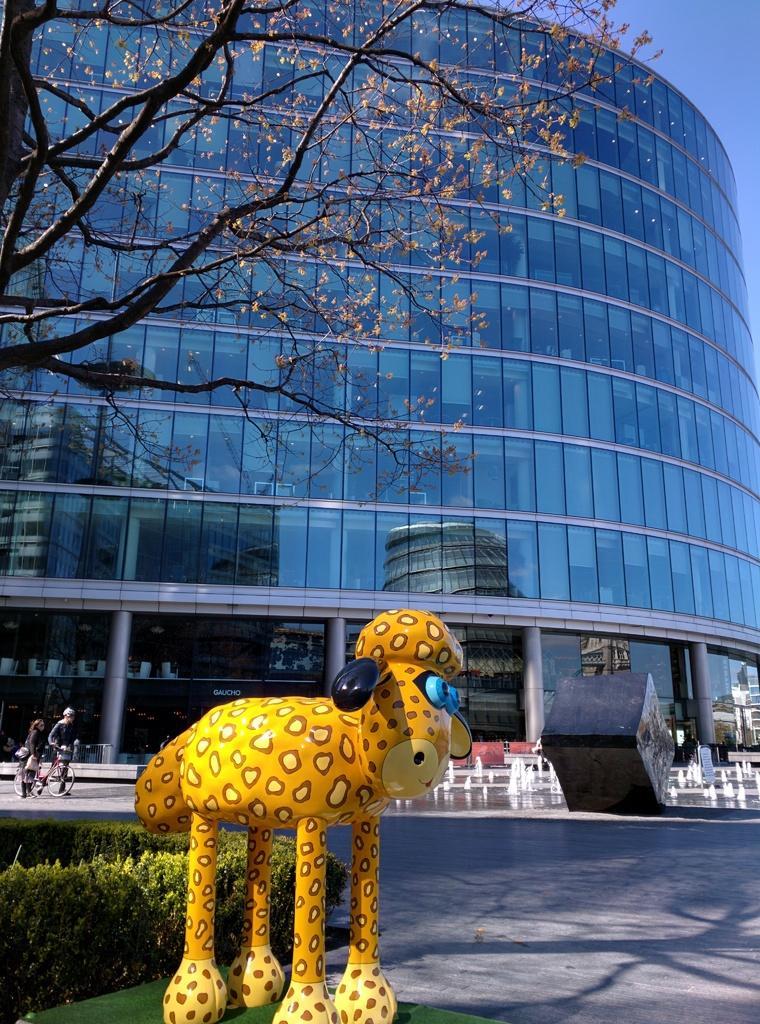How would you summarize this image in a sentence or two? In this picture I can see there is a yellow color toy and there are a few plants and in the backdrop there is a person holding a bicycle and there is a tree and in the backdrop there is a building, with glass windows and the sky is clear. 